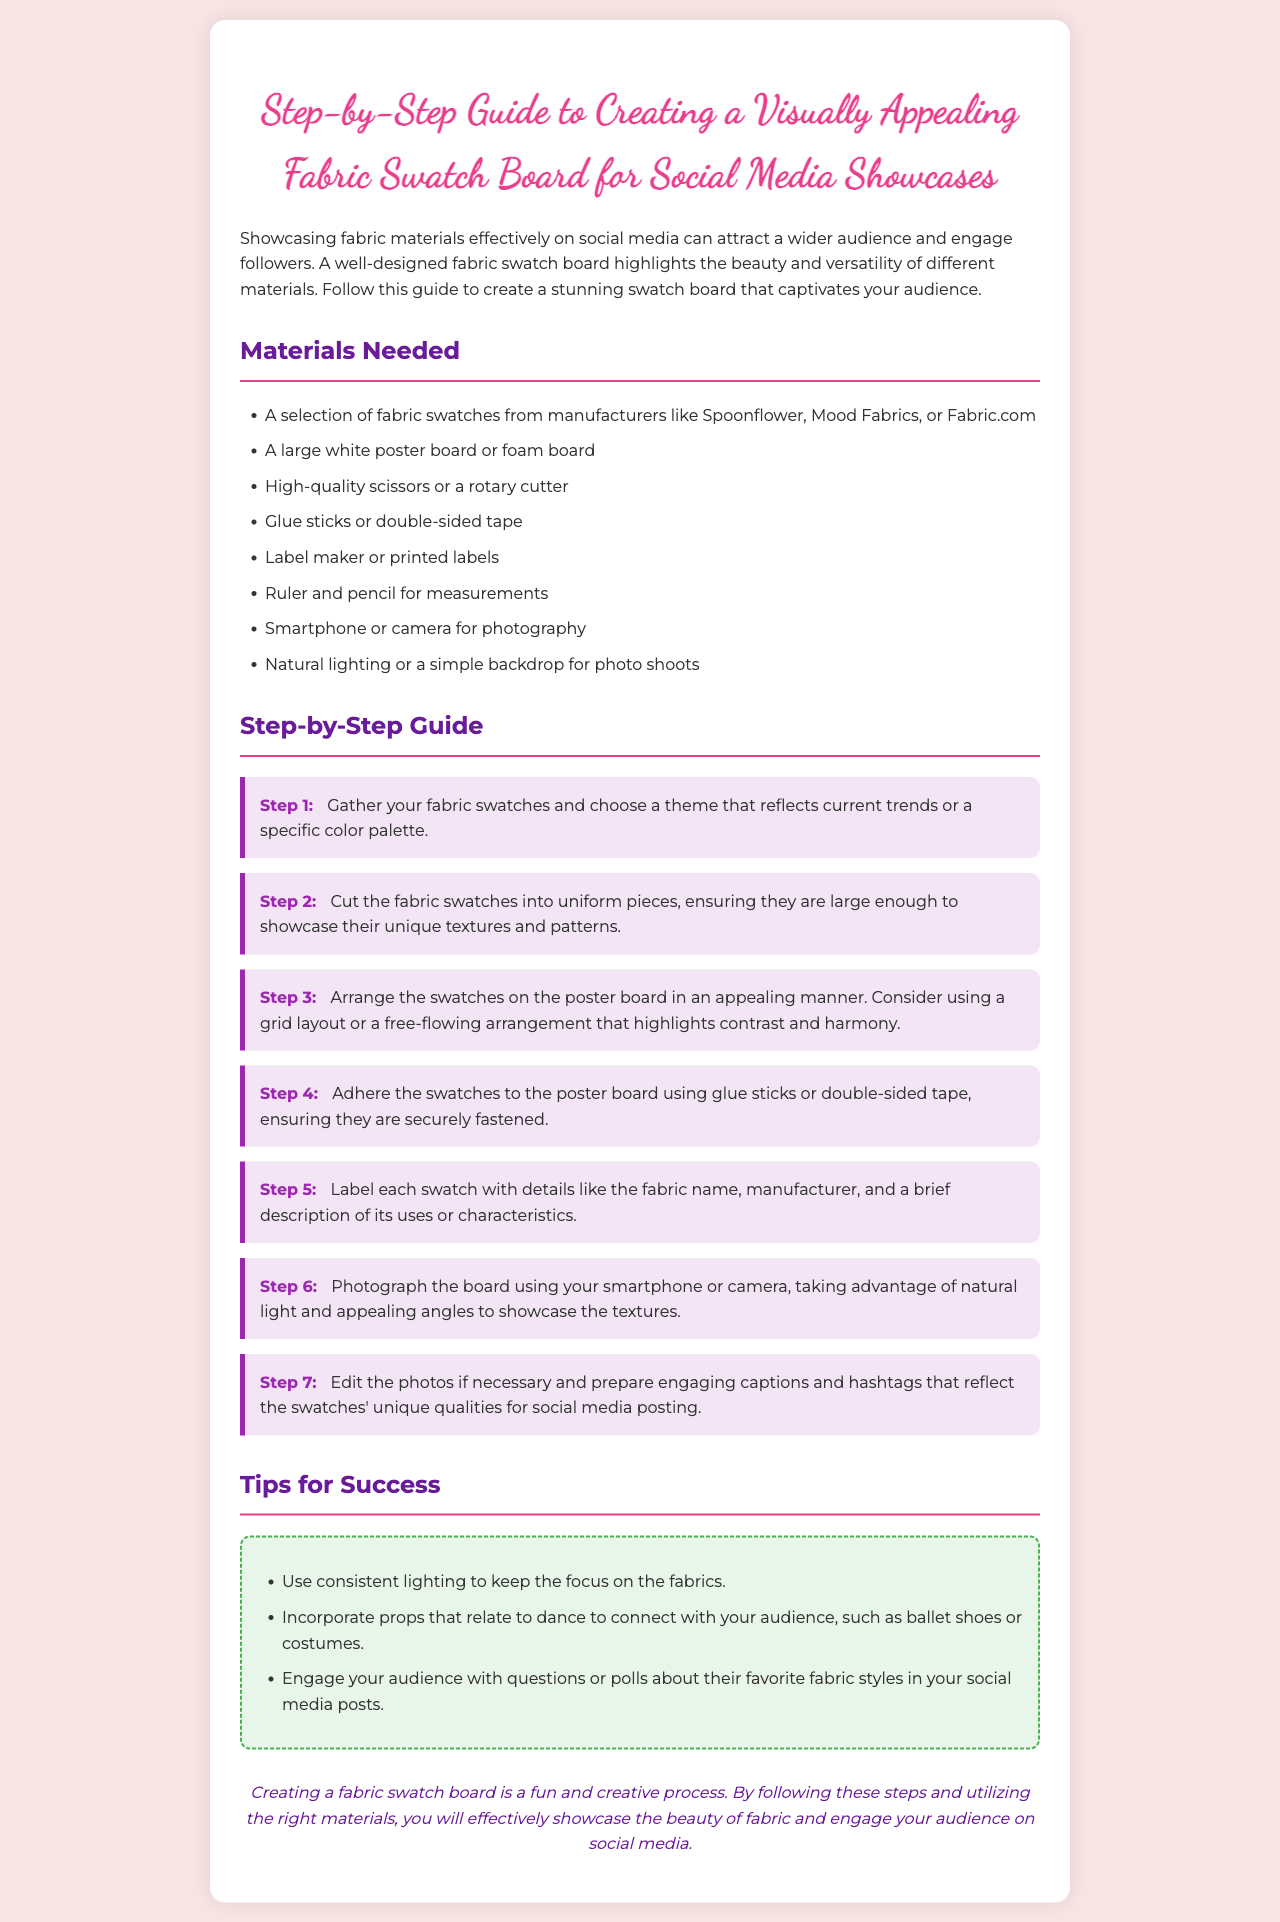What are the materials needed for the swatch board? The materials include a selection of fabric swatches, a large white poster board, scissors, glue, labels, a ruler, a smartphone or camera, and natural lighting.
Answer: Fabric swatches, poster board, scissors, glue, labels, ruler, smartphone, lighting How many steps are outlined in the guide? The guide outlines a total of seven steps for creating the fabric swatch board.
Answer: Seven What is the purpose of labeling the fabric swatches? Labeling helps provide details like the fabric name, manufacturer, and a brief description of its uses or characteristics.
Answer: Details about the fabric Which step involves photographing the board? Step six specifically mentions photographing the board using a smartphone or camera.
Answer: Step 6 What color is the background of the document? The background color of the document is light pink.
Answer: Light pink Why is consistent lighting recommended for the photos? Consistent lighting helps to keep the focus on the fabrics, showcasing their unique qualities effectively.
Answer: Focus on the fabrics What decorative element enhances the titles in the document? The titles are enhanced with a border and a distinct color, making them visually appealing.
Answer: Borders and color What kind of props can enhance engagement with the audience? Incorporating dance-related props, such as ballet shoes or costumes, can enhance audience engagement.
Answer: Dance-related props What is the design style encouraged for arranging fabric swatches? A grid layout or a free-flowing arrangement that highlights contrast and harmony is encouraged.
Answer: Grid layout or free-flowing arrangement 